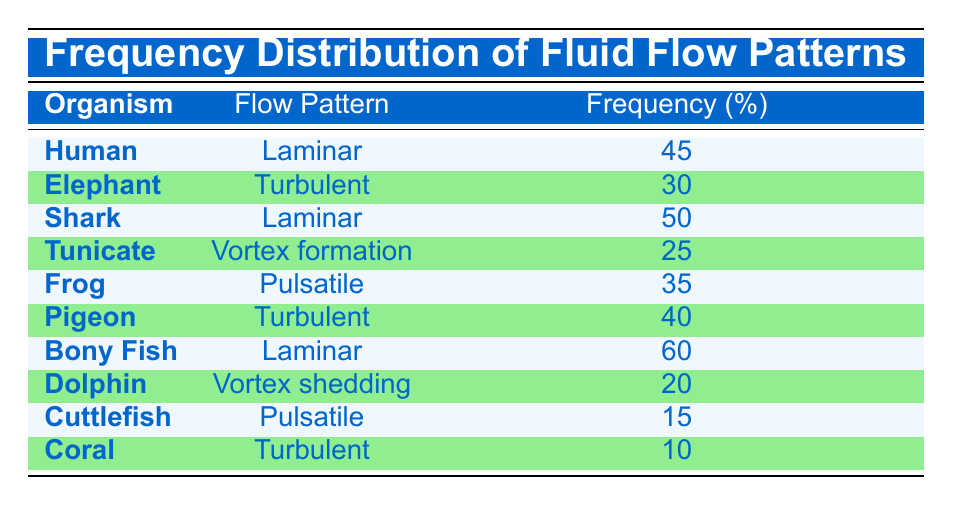What is the frequency percentage of fluid flow patterns for Bony Fish? According to the table, the frequency percentage for Bony Fish's flow pattern is listed directly as 60%.
Answer: 60% How many organisms exhibit Laminar flow patterns? From the table, there are three organisms that exhibit Laminar flow patterns: Human, Shark, and Bony Fish.
Answer: 3 What is the flow pattern with the highest frequency, and what is its frequency? The flow pattern with the highest frequency is Laminar, associated with Bony Fish, which has a frequency of 60%.
Answer: Laminar, 60% Is the frequency of Pulsatile flow patterns higher than that of Vortex shedding? The table shows that Pulsatile has a frequency of 35% (Frog) and 15% (Cuttlefish), while Vortex shedding has a frequency of 20% (Dolphin). Since 35% is greater than 20%, it is true that Pulsatile flow patterns have a higher frequency than Vortex shedding.
Answer: Yes What is the average frequency of the Turbulent flow patterns across all organisms? The Turbulent flow patterns have frequencies of 30% (Elephant), 40% (Pigeon), and 10% (Coral). To find the average, sum these frequencies: 30 + 40 + 10 = 80%. There are three organisms, so the average is 80/3 = approximately 26.67%.
Answer: 26.67% 